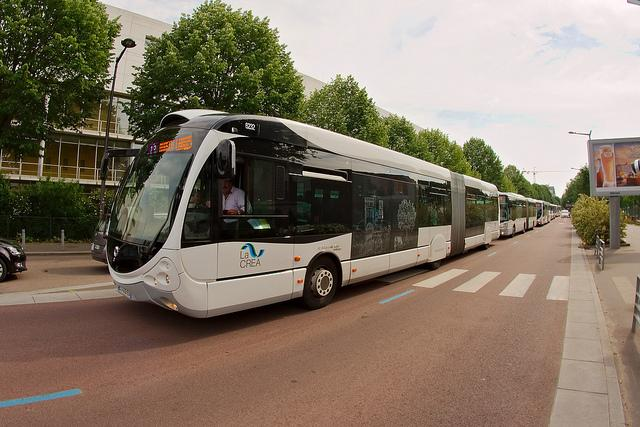What do the white markings on the road allow for here? Please explain your reasoning. crossing street. They denote a place for pedestrians to get across safely. 